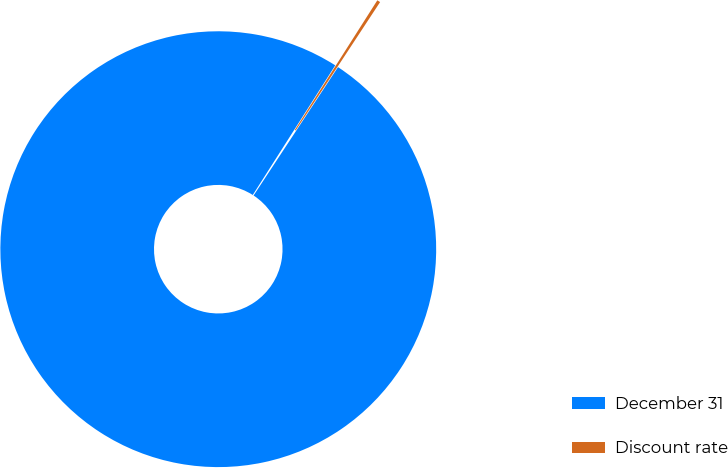Convert chart to OTSL. <chart><loc_0><loc_0><loc_500><loc_500><pie_chart><fcel>December 31<fcel>Discount rate<nl><fcel>99.76%<fcel>0.24%<nl></chart> 